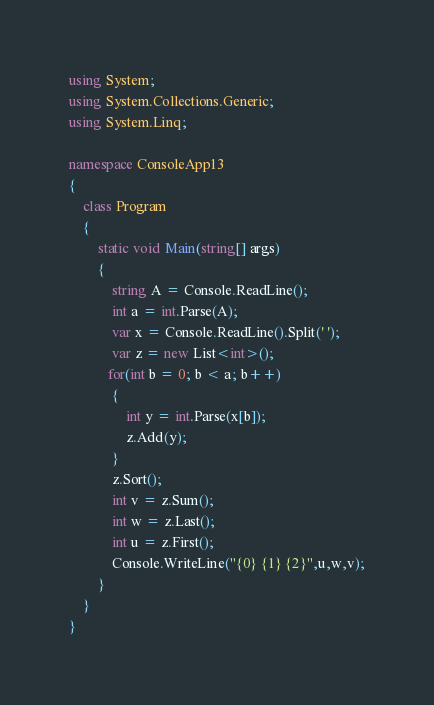<code> <loc_0><loc_0><loc_500><loc_500><_C#_>using System;
using System.Collections.Generic;
using System.Linq;

namespace ConsoleApp13
{
    class Program
    {
        static void Main(string[] args)
        {
            string A = Console.ReadLine();
            int a = int.Parse(A);
            var x = Console.ReadLine().Split(' ');
            var z = new List<int>();
           for(int b = 0; b < a; b++)
            {
                int y = int.Parse(x[b]);
                z.Add(y);
            }
            z.Sort();
            int v = z.Sum();
            int w = z.Last();
            int u = z.First();
            Console.WriteLine("{0} {1} {2}",u,w,v);
        }
    }
}</code> 